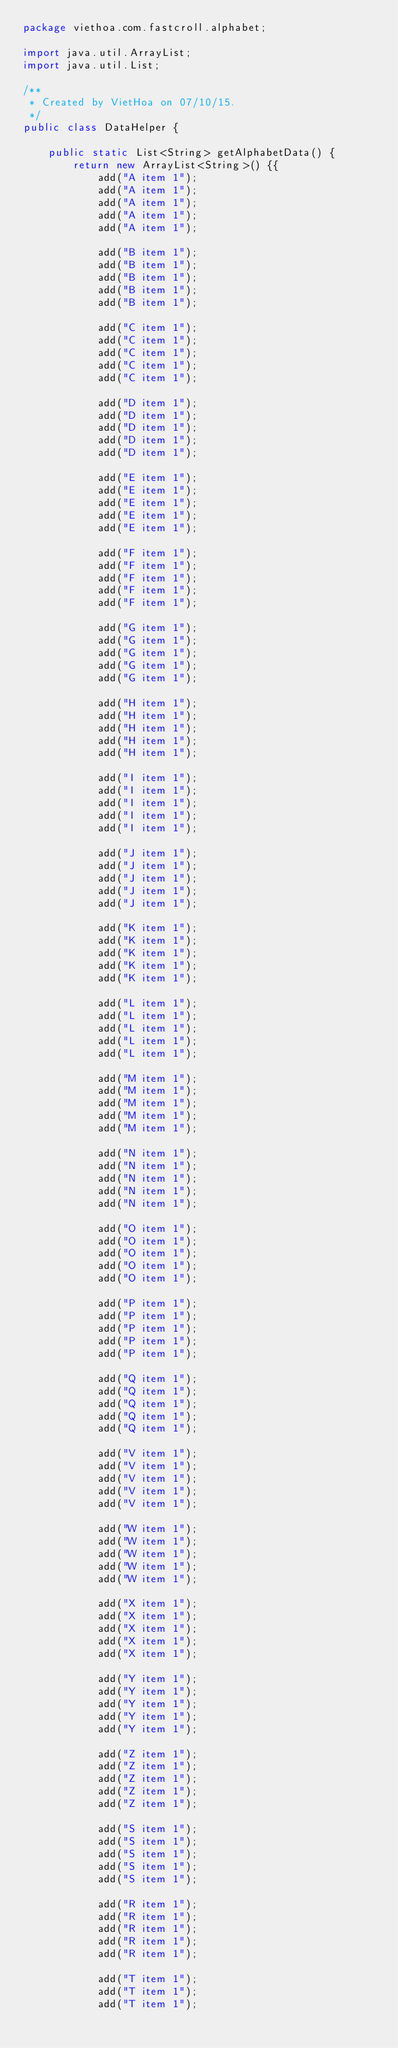Convert code to text. <code><loc_0><loc_0><loc_500><loc_500><_Java_>package viethoa.com.fastcroll.alphabet;

import java.util.ArrayList;
import java.util.List;

/**
 * Created by VietHoa on 07/10/15.
 */
public class DataHelper {

    public static List<String> getAlphabetData() {
        return new ArrayList<String>() {{
            add("A item 1");
            add("A item 1");
            add("A item 1");
            add("A item 1");
            add("A item 1");

            add("B item 1");
            add("B item 1");
            add("B item 1");
            add("B item 1");
            add("B item 1");

            add("C item 1");
            add("C item 1");
            add("C item 1");
            add("C item 1");
            add("C item 1");

            add("D item 1");
            add("D item 1");
            add("D item 1");
            add("D item 1");
            add("D item 1");

            add("E item 1");
            add("E item 1");
            add("E item 1");
            add("E item 1");
            add("E item 1");

            add("F item 1");
            add("F item 1");
            add("F item 1");
            add("F item 1");
            add("F item 1");

            add("G item 1");
            add("G item 1");
            add("G item 1");
            add("G item 1");
            add("G item 1");

            add("H item 1");
            add("H item 1");
            add("H item 1");
            add("H item 1");
            add("H item 1");

            add("I item 1");
            add("I item 1");
            add("I item 1");
            add("I item 1");
            add("I item 1");

            add("J item 1");
            add("J item 1");
            add("J item 1");
            add("J item 1");
            add("J item 1");

            add("K item 1");
            add("K item 1");
            add("K item 1");
            add("K item 1");
            add("K item 1");

            add("L item 1");
            add("L item 1");
            add("L item 1");
            add("L item 1");
            add("L item 1");

            add("M item 1");
            add("M item 1");
            add("M item 1");
            add("M item 1");
            add("M item 1");

            add("N item 1");
            add("N item 1");
            add("N item 1");
            add("N item 1");
            add("N item 1");

            add("O item 1");
            add("O item 1");
            add("O item 1");
            add("O item 1");
            add("O item 1");

            add("P item 1");
            add("P item 1");
            add("P item 1");
            add("P item 1");
            add("P item 1");

            add("Q item 1");
            add("Q item 1");
            add("Q item 1");
            add("Q item 1");
            add("Q item 1");

            add("V item 1");
            add("V item 1");
            add("V item 1");
            add("V item 1");
            add("V item 1");

            add("W item 1");
            add("W item 1");
            add("W item 1");
            add("W item 1");
            add("W item 1");

            add("X item 1");
            add("X item 1");
            add("X item 1");
            add("X item 1");
            add("X item 1");

            add("Y item 1");
            add("Y item 1");
            add("Y item 1");
            add("Y item 1");
            add("Y item 1");

            add("Z item 1");
            add("Z item 1");
            add("Z item 1");
            add("Z item 1");
            add("Z item 1");

            add("S item 1");
            add("S item 1");
            add("S item 1");
            add("S item 1");
            add("S item 1");

            add("R item 1");
            add("R item 1");
            add("R item 1");
            add("R item 1");
            add("R item 1");

            add("T item 1");
            add("T item 1");
            add("T item 1");</code> 